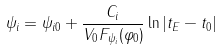<formula> <loc_0><loc_0><loc_500><loc_500>\psi _ { i } = \psi _ { i 0 } + \frac { C _ { i } } { V _ { 0 } F _ { \psi _ { i } } ( \varphi _ { 0 } ) } \ln | t _ { E } - t _ { 0 } |</formula> 